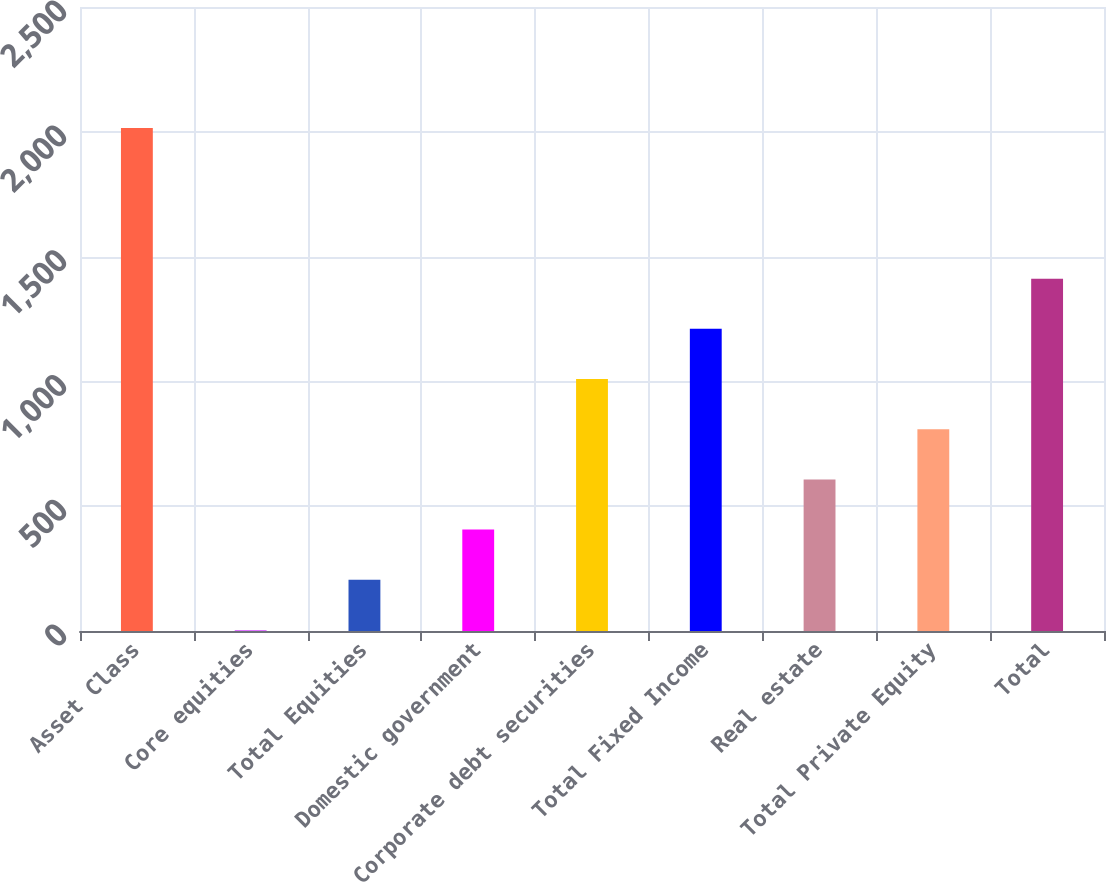<chart> <loc_0><loc_0><loc_500><loc_500><bar_chart><fcel>Asset Class<fcel>Core equities<fcel>Total Equities<fcel>Domestic government<fcel>Corporate debt securities<fcel>Total Fixed Income<fcel>Real estate<fcel>Total Private Equity<fcel>Total<nl><fcel>2015<fcel>4<fcel>205.1<fcel>406.2<fcel>1009.5<fcel>1210.6<fcel>607.3<fcel>808.4<fcel>1411.7<nl></chart> 